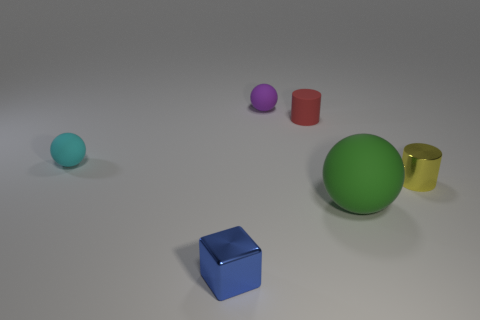Is there a yellow object that has the same material as the block?
Provide a short and direct response. Yes. There is a cylinder behind the tiny cyan matte ball; does it have the same size as the rubber ball that is to the left of the small blue metallic thing?
Provide a short and direct response. Yes. There is a matte ball on the left side of the metallic cube; how big is it?
Ensure brevity in your answer.  Small. There is a tiny matte thing behind the red thing; is there a small matte thing that is on the left side of it?
Provide a short and direct response. Yes. Do the red cylinder and the shiny object on the left side of the yellow thing have the same size?
Make the answer very short. Yes. There is a small cylinder that is left of the shiny thing that is behind the tiny metallic block; is there a small cylinder behind it?
Your response must be concise. No. There is a cylinder to the left of the yellow shiny cylinder; what is its material?
Your answer should be compact. Rubber. Do the purple object and the red matte thing have the same size?
Keep it short and to the point. Yes. There is a small object that is on the left side of the purple matte object and behind the metallic cylinder; what is its color?
Keep it short and to the point. Cyan. What shape is the big object that is the same material as the small purple object?
Make the answer very short. Sphere. 